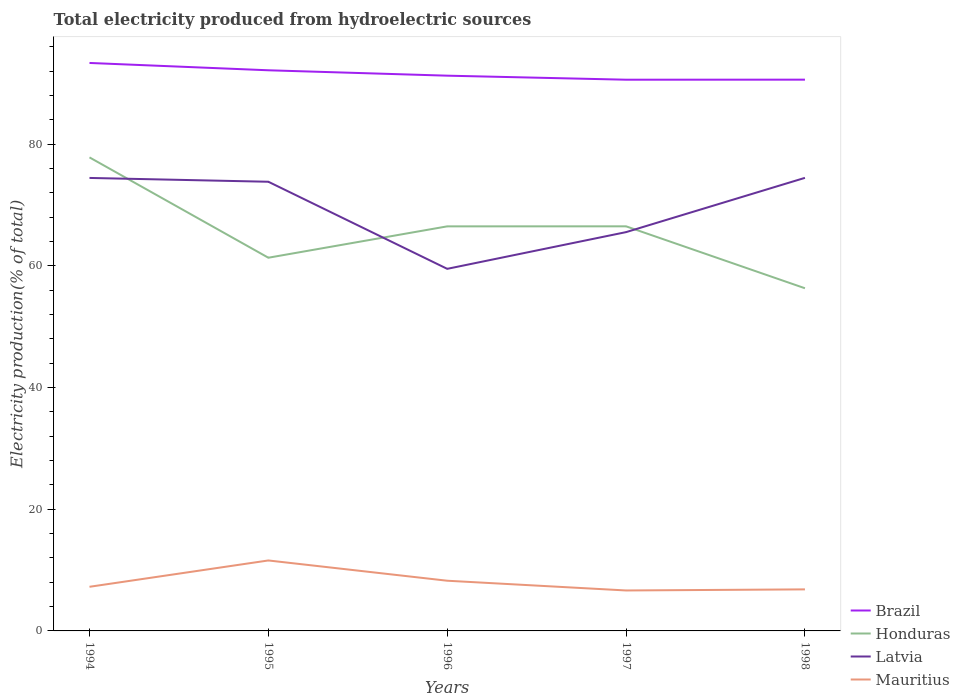How many different coloured lines are there?
Keep it short and to the point. 4. Across all years, what is the maximum total electricity produced in Brazil?
Ensure brevity in your answer.  90.58. What is the total total electricity produced in Latvia in the graph?
Your answer should be very brief. -14.95. What is the difference between the highest and the second highest total electricity produced in Latvia?
Provide a short and direct response. 14.95. How many years are there in the graph?
Provide a short and direct response. 5. Are the values on the major ticks of Y-axis written in scientific E-notation?
Your answer should be compact. No. Does the graph contain any zero values?
Offer a very short reply. No. Does the graph contain grids?
Offer a terse response. No. Where does the legend appear in the graph?
Your answer should be compact. Bottom right. What is the title of the graph?
Your answer should be compact. Total electricity produced from hydroelectric sources. What is the label or title of the Y-axis?
Your answer should be compact. Electricity production(% of total). What is the Electricity production(% of total) of Brazil in 1994?
Offer a terse response. 93.33. What is the Electricity production(% of total) of Honduras in 1994?
Offer a terse response. 77.82. What is the Electricity production(% of total) in Latvia in 1994?
Offer a very short reply. 74.44. What is the Electricity production(% of total) in Mauritius in 1994?
Your answer should be very brief. 7.25. What is the Electricity production(% of total) in Brazil in 1995?
Make the answer very short. 92.13. What is the Electricity production(% of total) of Honduras in 1995?
Your answer should be very brief. 61.33. What is the Electricity production(% of total) of Latvia in 1995?
Provide a succinct answer. 73.81. What is the Electricity production(% of total) of Mauritius in 1995?
Provide a succinct answer. 11.58. What is the Electricity production(% of total) in Brazil in 1996?
Provide a succinct answer. 91.24. What is the Electricity production(% of total) of Honduras in 1996?
Provide a short and direct response. 66.48. What is the Electricity production(% of total) of Latvia in 1996?
Your answer should be very brief. 59.5. What is the Electricity production(% of total) of Mauritius in 1996?
Your answer should be compact. 8.25. What is the Electricity production(% of total) of Brazil in 1997?
Your answer should be compact. 90.58. What is the Electricity production(% of total) in Honduras in 1997?
Your response must be concise. 66.49. What is the Electricity production(% of total) of Latvia in 1997?
Ensure brevity in your answer.  65.53. What is the Electricity production(% of total) in Mauritius in 1997?
Give a very brief answer. 6.65. What is the Electricity production(% of total) in Brazil in 1998?
Ensure brevity in your answer.  90.59. What is the Electricity production(% of total) in Honduras in 1998?
Provide a short and direct response. 56.31. What is the Electricity production(% of total) in Latvia in 1998?
Your answer should be compact. 74.45. What is the Electricity production(% of total) of Mauritius in 1998?
Your answer should be very brief. 6.83. Across all years, what is the maximum Electricity production(% of total) in Brazil?
Offer a terse response. 93.33. Across all years, what is the maximum Electricity production(% of total) of Honduras?
Make the answer very short. 77.82. Across all years, what is the maximum Electricity production(% of total) in Latvia?
Offer a terse response. 74.45. Across all years, what is the maximum Electricity production(% of total) of Mauritius?
Offer a terse response. 11.58. Across all years, what is the minimum Electricity production(% of total) in Brazil?
Ensure brevity in your answer.  90.58. Across all years, what is the minimum Electricity production(% of total) of Honduras?
Provide a short and direct response. 56.31. Across all years, what is the minimum Electricity production(% of total) in Latvia?
Provide a short and direct response. 59.5. Across all years, what is the minimum Electricity production(% of total) in Mauritius?
Your answer should be compact. 6.65. What is the total Electricity production(% of total) in Brazil in the graph?
Offer a terse response. 457.87. What is the total Electricity production(% of total) in Honduras in the graph?
Make the answer very short. 328.42. What is the total Electricity production(% of total) of Latvia in the graph?
Provide a short and direct response. 347.74. What is the total Electricity production(% of total) in Mauritius in the graph?
Offer a terse response. 40.55. What is the difference between the Electricity production(% of total) of Brazil in 1994 and that in 1995?
Your answer should be compact. 1.21. What is the difference between the Electricity production(% of total) of Honduras in 1994 and that in 1995?
Give a very brief answer. 16.49. What is the difference between the Electricity production(% of total) in Latvia in 1994 and that in 1995?
Give a very brief answer. 0.62. What is the difference between the Electricity production(% of total) of Mauritius in 1994 and that in 1995?
Provide a short and direct response. -4.33. What is the difference between the Electricity production(% of total) in Brazil in 1994 and that in 1996?
Your answer should be compact. 2.09. What is the difference between the Electricity production(% of total) in Honduras in 1994 and that in 1996?
Provide a succinct answer. 11.33. What is the difference between the Electricity production(% of total) in Latvia in 1994 and that in 1996?
Your answer should be very brief. 14.94. What is the difference between the Electricity production(% of total) of Mauritius in 1994 and that in 1996?
Keep it short and to the point. -1. What is the difference between the Electricity production(% of total) of Brazil in 1994 and that in 1997?
Keep it short and to the point. 2.75. What is the difference between the Electricity production(% of total) in Honduras in 1994 and that in 1997?
Provide a succinct answer. 11.33. What is the difference between the Electricity production(% of total) in Latvia in 1994 and that in 1997?
Provide a succinct answer. 8.9. What is the difference between the Electricity production(% of total) in Mauritius in 1994 and that in 1997?
Provide a succinct answer. 0.6. What is the difference between the Electricity production(% of total) of Brazil in 1994 and that in 1998?
Keep it short and to the point. 2.74. What is the difference between the Electricity production(% of total) of Honduras in 1994 and that in 1998?
Ensure brevity in your answer.  21.51. What is the difference between the Electricity production(% of total) of Latvia in 1994 and that in 1998?
Give a very brief answer. -0.02. What is the difference between the Electricity production(% of total) of Mauritius in 1994 and that in 1998?
Make the answer very short. 0.42. What is the difference between the Electricity production(% of total) in Brazil in 1995 and that in 1996?
Your response must be concise. 0.89. What is the difference between the Electricity production(% of total) in Honduras in 1995 and that in 1996?
Make the answer very short. -5.15. What is the difference between the Electricity production(% of total) of Latvia in 1995 and that in 1996?
Give a very brief answer. 14.31. What is the difference between the Electricity production(% of total) of Mauritius in 1995 and that in 1996?
Keep it short and to the point. 3.33. What is the difference between the Electricity production(% of total) in Brazil in 1995 and that in 1997?
Your answer should be very brief. 1.55. What is the difference between the Electricity production(% of total) in Honduras in 1995 and that in 1997?
Provide a succinct answer. -5.16. What is the difference between the Electricity production(% of total) in Latvia in 1995 and that in 1997?
Offer a very short reply. 8.28. What is the difference between the Electricity production(% of total) of Mauritius in 1995 and that in 1997?
Make the answer very short. 4.93. What is the difference between the Electricity production(% of total) in Brazil in 1995 and that in 1998?
Ensure brevity in your answer.  1.54. What is the difference between the Electricity production(% of total) of Honduras in 1995 and that in 1998?
Your answer should be very brief. 5.02. What is the difference between the Electricity production(% of total) in Latvia in 1995 and that in 1998?
Your answer should be compact. -0.64. What is the difference between the Electricity production(% of total) of Mauritius in 1995 and that in 1998?
Keep it short and to the point. 4.75. What is the difference between the Electricity production(% of total) of Brazil in 1996 and that in 1997?
Your answer should be very brief. 0.66. What is the difference between the Electricity production(% of total) of Honduras in 1996 and that in 1997?
Give a very brief answer. -0. What is the difference between the Electricity production(% of total) in Latvia in 1996 and that in 1997?
Keep it short and to the point. -6.03. What is the difference between the Electricity production(% of total) in Mauritius in 1996 and that in 1997?
Your response must be concise. 1.6. What is the difference between the Electricity production(% of total) in Brazil in 1996 and that in 1998?
Give a very brief answer. 0.65. What is the difference between the Electricity production(% of total) in Honduras in 1996 and that in 1998?
Keep it short and to the point. 10.17. What is the difference between the Electricity production(% of total) of Latvia in 1996 and that in 1998?
Keep it short and to the point. -14.95. What is the difference between the Electricity production(% of total) of Mauritius in 1996 and that in 1998?
Offer a very short reply. 1.42. What is the difference between the Electricity production(% of total) in Brazil in 1997 and that in 1998?
Your answer should be very brief. -0.01. What is the difference between the Electricity production(% of total) of Honduras in 1997 and that in 1998?
Your response must be concise. 10.18. What is the difference between the Electricity production(% of total) of Latvia in 1997 and that in 1998?
Your answer should be compact. -8.92. What is the difference between the Electricity production(% of total) in Mauritius in 1997 and that in 1998?
Offer a very short reply. -0.18. What is the difference between the Electricity production(% of total) of Brazil in 1994 and the Electricity production(% of total) of Honduras in 1995?
Your response must be concise. 32.01. What is the difference between the Electricity production(% of total) in Brazil in 1994 and the Electricity production(% of total) in Latvia in 1995?
Provide a short and direct response. 19.52. What is the difference between the Electricity production(% of total) of Brazil in 1994 and the Electricity production(% of total) of Mauritius in 1995?
Make the answer very short. 81.76. What is the difference between the Electricity production(% of total) in Honduras in 1994 and the Electricity production(% of total) in Latvia in 1995?
Your answer should be very brief. 4. What is the difference between the Electricity production(% of total) of Honduras in 1994 and the Electricity production(% of total) of Mauritius in 1995?
Give a very brief answer. 66.24. What is the difference between the Electricity production(% of total) in Latvia in 1994 and the Electricity production(% of total) in Mauritius in 1995?
Your answer should be compact. 62.86. What is the difference between the Electricity production(% of total) in Brazil in 1994 and the Electricity production(% of total) in Honduras in 1996?
Your answer should be very brief. 26.85. What is the difference between the Electricity production(% of total) in Brazil in 1994 and the Electricity production(% of total) in Latvia in 1996?
Ensure brevity in your answer.  33.83. What is the difference between the Electricity production(% of total) in Brazil in 1994 and the Electricity production(% of total) in Mauritius in 1996?
Offer a terse response. 85.09. What is the difference between the Electricity production(% of total) in Honduras in 1994 and the Electricity production(% of total) in Latvia in 1996?
Your answer should be compact. 18.31. What is the difference between the Electricity production(% of total) in Honduras in 1994 and the Electricity production(% of total) in Mauritius in 1996?
Provide a succinct answer. 69.57. What is the difference between the Electricity production(% of total) in Latvia in 1994 and the Electricity production(% of total) in Mauritius in 1996?
Ensure brevity in your answer.  66.19. What is the difference between the Electricity production(% of total) in Brazil in 1994 and the Electricity production(% of total) in Honduras in 1997?
Your answer should be compact. 26.85. What is the difference between the Electricity production(% of total) of Brazil in 1994 and the Electricity production(% of total) of Latvia in 1997?
Your response must be concise. 27.8. What is the difference between the Electricity production(% of total) of Brazil in 1994 and the Electricity production(% of total) of Mauritius in 1997?
Provide a succinct answer. 86.69. What is the difference between the Electricity production(% of total) in Honduras in 1994 and the Electricity production(% of total) in Latvia in 1997?
Offer a terse response. 12.28. What is the difference between the Electricity production(% of total) in Honduras in 1994 and the Electricity production(% of total) in Mauritius in 1997?
Ensure brevity in your answer.  71.17. What is the difference between the Electricity production(% of total) of Latvia in 1994 and the Electricity production(% of total) of Mauritius in 1997?
Keep it short and to the point. 67.79. What is the difference between the Electricity production(% of total) in Brazil in 1994 and the Electricity production(% of total) in Honduras in 1998?
Make the answer very short. 37.02. What is the difference between the Electricity production(% of total) in Brazil in 1994 and the Electricity production(% of total) in Latvia in 1998?
Give a very brief answer. 18.88. What is the difference between the Electricity production(% of total) in Brazil in 1994 and the Electricity production(% of total) in Mauritius in 1998?
Provide a short and direct response. 86.51. What is the difference between the Electricity production(% of total) in Honduras in 1994 and the Electricity production(% of total) in Latvia in 1998?
Your response must be concise. 3.36. What is the difference between the Electricity production(% of total) in Honduras in 1994 and the Electricity production(% of total) in Mauritius in 1998?
Your answer should be compact. 70.99. What is the difference between the Electricity production(% of total) of Latvia in 1994 and the Electricity production(% of total) of Mauritius in 1998?
Give a very brief answer. 67.61. What is the difference between the Electricity production(% of total) of Brazil in 1995 and the Electricity production(% of total) of Honduras in 1996?
Make the answer very short. 25.65. What is the difference between the Electricity production(% of total) in Brazil in 1995 and the Electricity production(% of total) in Latvia in 1996?
Make the answer very short. 32.63. What is the difference between the Electricity production(% of total) of Brazil in 1995 and the Electricity production(% of total) of Mauritius in 1996?
Your response must be concise. 83.88. What is the difference between the Electricity production(% of total) in Honduras in 1995 and the Electricity production(% of total) in Latvia in 1996?
Offer a terse response. 1.83. What is the difference between the Electricity production(% of total) of Honduras in 1995 and the Electricity production(% of total) of Mauritius in 1996?
Your response must be concise. 53.08. What is the difference between the Electricity production(% of total) in Latvia in 1995 and the Electricity production(% of total) in Mauritius in 1996?
Your response must be concise. 65.56. What is the difference between the Electricity production(% of total) of Brazil in 1995 and the Electricity production(% of total) of Honduras in 1997?
Your answer should be very brief. 25.64. What is the difference between the Electricity production(% of total) in Brazil in 1995 and the Electricity production(% of total) in Latvia in 1997?
Give a very brief answer. 26.59. What is the difference between the Electricity production(% of total) in Brazil in 1995 and the Electricity production(% of total) in Mauritius in 1997?
Your response must be concise. 85.48. What is the difference between the Electricity production(% of total) of Honduras in 1995 and the Electricity production(% of total) of Latvia in 1997?
Keep it short and to the point. -4.21. What is the difference between the Electricity production(% of total) of Honduras in 1995 and the Electricity production(% of total) of Mauritius in 1997?
Provide a short and direct response. 54.68. What is the difference between the Electricity production(% of total) of Latvia in 1995 and the Electricity production(% of total) of Mauritius in 1997?
Keep it short and to the point. 67.16. What is the difference between the Electricity production(% of total) of Brazil in 1995 and the Electricity production(% of total) of Honduras in 1998?
Offer a terse response. 35.82. What is the difference between the Electricity production(% of total) in Brazil in 1995 and the Electricity production(% of total) in Latvia in 1998?
Your answer should be compact. 17.68. What is the difference between the Electricity production(% of total) in Brazil in 1995 and the Electricity production(% of total) in Mauritius in 1998?
Your answer should be compact. 85.3. What is the difference between the Electricity production(% of total) of Honduras in 1995 and the Electricity production(% of total) of Latvia in 1998?
Provide a succinct answer. -13.13. What is the difference between the Electricity production(% of total) of Honduras in 1995 and the Electricity production(% of total) of Mauritius in 1998?
Your answer should be very brief. 54.5. What is the difference between the Electricity production(% of total) of Latvia in 1995 and the Electricity production(% of total) of Mauritius in 1998?
Your answer should be very brief. 66.99. What is the difference between the Electricity production(% of total) in Brazil in 1996 and the Electricity production(% of total) in Honduras in 1997?
Your answer should be compact. 24.76. What is the difference between the Electricity production(% of total) of Brazil in 1996 and the Electricity production(% of total) of Latvia in 1997?
Keep it short and to the point. 25.71. What is the difference between the Electricity production(% of total) in Brazil in 1996 and the Electricity production(% of total) in Mauritius in 1997?
Offer a terse response. 84.59. What is the difference between the Electricity production(% of total) of Honduras in 1996 and the Electricity production(% of total) of Latvia in 1997?
Keep it short and to the point. 0.95. What is the difference between the Electricity production(% of total) in Honduras in 1996 and the Electricity production(% of total) in Mauritius in 1997?
Your response must be concise. 59.83. What is the difference between the Electricity production(% of total) of Latvia in 1996 and the Electricity production(% of total) of Mauritius in 1997?
Make the answer very short. 52.85. What is the difference between the Electricity production(% of total) of Brazil in 1996 and the Electricity production(% of total) of Honduras in 1998?
Provide a short and direct response. 34.93. What is the difference between the Electricity production(% of total) of Brazil in 1996 and the Electricity production(% of total) of Latvia in 1998?
Make the answer very short. 16.79. What is the difference between the Electricity production(% of total) of Brazil in 1996 and the Electricity production(% of total) of Mauritius in 1998?
Your answer should be very brief. 84.42. What is the difference between the Electricity production(% of total) in Honduras in 1996 and the Electricity production(% of total) in Latvia in 1998?
Your answer should be very brief. -7.97. What is the difference between the Electricity production(% of total) of Honduras in 1996 and the Electricity production(% of total) of Mauritius in 1998?
Offer a very short reply. 59.65. What is the difference between the Electricity production(% of total) of Latvia in 1996 and the Electricity production(% of total) of Mauritius in 1998?
Your response must be concise. 52.67. What is the difference between the Electricity production(% of total) of Brazil in 1997 and the Electricity production(% of total) of Honduras in 1998?
Provide a succinct answer. 34.27. What is the difference between the Electricity production(% of total) in Brazil in 1997 and the Electricity production(% of total) in Latvia in 1998?
Your response must be concise. 16.13. What is the difference between the Electricity production(% of total) in Brazil in 1997 and the Electricity production(% of total) in Mauritius in 1998?
Provide a succinct answer. 83.75. What is the difference between the Electricity production(% of total) of Honduras in 1997 and the Electricity production(% of total) of Latvia in 1998?
Make the answer very short. -7.97. What is the difference between the Electricity production(% of total) of Honduras in 1997 and the Electricity production(% of total) of Mauritius in 1998?
Your answer should be compact. 59.66. What is the difference between the Electricity production(% of total) of Latvia in 1997 and the Electricity production(% of total) of Mauritius in 1998?
Give a very brief answer. 58.71. What is the average Electricity production(% of total) in Brazil per year?
Give a very brief answer. 91.57. What is the average Electricity production(% of total) of Honduras per year?
Your answer should be very brief. 65.68. What is the average Electricity production(% of total) of Latvia per year?
Make the answer very short. 69.55. What is the average Electricity production(% of total) of Mauritius per year?
Provide a succinct answer. 8.11. In the year 1994, what is the difference between the Electricity production(% of total) in Brazil and Electricity production(% of total) in Honduras?
Offer a terse response. 15.52. In the year 1994, what is the difference between the Electricity production(% of total) of Brazil and Electricity production(% of total) of Latvia?
Your answer should be compact. 18.9. In the year 1994, what is the difference between the Electricity production(% of total) in Brazil and Electricity production(% of total) in Mauritius?
Give a very brief answer. 86.08. In the year 1994, what is the difference between the Electricity production(% of total) in Honduras and Electricity production(% of total) in Latvia?
Provide a succinct answer. 3.38. In the year 1994, what is the difference between the Electricity production(% of total) of Honduras and Electricity production(% of total) of Mauritius?
Give a very brief answer. 70.56. In the year 1994, what is the difference between the Electricity production(% of total) of Latvia and Electricity production(% of total) of Mauritius?
Make the answer very short. 67.19. In the year 1995, what is the difference between the Electricity production(% of total) of Brazil and Electricity production(% of total) of Honduras?
Offer a very short reply. 30.8. In the year 1995, what is the difference between the Electricity production(% of total) in Brazil and Electricity production(% of total) in Latvia?
Offer a very short reply. 18.32. In the year 1995, what is the difference between the Electricity production(% of total) in Brazil and Electricity production(% of total) in Mauritius?
Your response must be concise. 80.55. In the year 1995, what is the difference between the Electricity production(% of total) in Honduras and Electricity production(% of total) in Latvia?
Your answer should be very brief. -12.49. In the year 1995, what is the difference between the Electricity production(% of total) in Honduras and Electricity production(% of total) in Mauritius?
Offer a terse response. 49.75. In the year 1995, what is the difference between the Electricity production(% of total) in Latvia and Electricity production(% of total) in Mauritius?
Offer a very short reply. 62.23. In the year 1996, what is the difference between the Electricity production(% of total) in Brazil and Electricity production(% of total) in Honduras?
Make the answer very short. 24.76. In the year 1996, what is the difference between the Electricity production(% of total) in Brazil and Electricity production(% of total) in Latvia?
Offer a terse response. 31.74. In the year 1996, what is the difference between the Electricity production(% of total) of Brazil and Electricity production(% of total) of Mauritius?
Make the answer very short. 82.99. In the year 1996, what is the difference between the Electricity production(% of total) of Honduras and Electricity production(% of total) of Latvia?
Your answer should be compact. 6.98. In the year 1996, what is the difference between the Electricity production(% of total) in Honduras and Electricity production(% of total) in Mauritius?
Your response must be concise. 58.23. In the year 1996, what is the difference between the Electricity production(% of total) of Latvia and Electricity production(% of total) of Mauritius?
Your answer should be very brief. 51.25. In the year 1997, what is the difference between the Electricity production(% of total) of Brazil and Electricity production(% of total) of Honduras?
Your response must be concise. 24.09. In the year 1997, what is the difference between the Electricity production(% of total) in Brazil and Electricity production(% of total) in Latvia?
Your response must be concise. 25.05. In the year 1997, what is the difference between the Electricity production(% of total) of Brazil and Electricity production(% of total) of Mauritius?
Provide a succinct answer. 83.93. In the year 1997, what is the difference between the Electricity production(% of total) of Honduras and Electricity production(% of total) of Latvia?
Your answer should be very brief. 0.95. In the year 1997, what is the difference between the Electricity production(% of total) in Honduras and Electricity production(% of total) in Mauritius?
Ensure brevity in your answer.  59.84. In the year 1997, what is the difference between the Electricity production(% of total) of Latvia and Electricity production(% of total) of Mauritius?
Your response must be concise. 58.89. In the year 1998, what is the difference between the Electricity production(% of total) in Brazil and Electricity production(% of total) in Honduras?
Offer a terse response. 34.28. In the year 1998, what is the difference between the Electricity production(% of total) of Brazil and Electricity production(% of total) of Latvia?
Ensure brevity in your answer.  16.14. In the year 1998, what is the difference between the Electricity production(% of total) of Brazil and Electricity production(% of total) of Mauritius?
Provide a succinct answer. 83.76. In the year 1998, what is the difference between the Electricity production(% of total) in Honduras and Electricity production(% of total) in Latvia?
Your answer should be compact. -18.14. In the year 1998, what is the difference between the Electricity production(% of total) of Honduras and Electricity production(% of total) of Mauritius?
Ensure brevity in your answer.  49.48. In the year 1998, what is the difference between the Electricity production(% of total) in Latvia and Electricity production(% of total) in Mauritius?
Ensure brevity in your answer.  67.63. What is the ratio of the Electricity production(% of total) in Brazil in 1994 to that in 1995?
Give a very brief answer. 1.01. What is the ratio of the Electricity production(% of total) of Honduras in 1994 to that in 1995?
Your answer should be compact. 1.27. What is the ratio of the Electricity production(% of total) of Latvia in 1994 to that in 1995?
Your answer should be compact. 1.01. What is the ratio of the Electricity production(% of total) of Mauritius in 1994 to that in 1995?
Ensure brevity in your answer.  0.63. What is the ratio of the Electricity production(% of total) in Brazil in 1994 to that in 1996?
Give a very brief answer. 1.02. What is the ratio of the Electricity production(% of total) in Honduras in 1994 to that in 1996?
Offer a terse response. 1.17. What is the ratio of the Electricity production(% of total) in Latvia in 1994 to that in 1996?
Your response must be concise. 1.25. What is the ratio of the Electricity production(% of total) of Mauritius in 1994 to that in 1996?
Ensure brevity in your answer.  0.88. What is the ratio of the Electricity production(% of total) in Brazil in 1994 to that in 1997?
Keep it short and to the point. 1.03. What is the ratio of the Electricity production(% of total) in Honduras in 1994 to that in 1997?
Ensure brevity in your answer.  1.17. What is the ratio of the Electricity production(% of total) in Latvia in 1994 to that in 1997?
Your answer should be compact. 1.14. What is the ratio of the Electricity production(% of total) of Brazil in 1994 to that in 1998?
Your response must be concise. 1.03. What is the ratio of the Electricity production(% of total) in Honduras in 1994 to that in 1998?
Your response must be concise. 1.38. What is the ratio of the Electricity production(% of total) in Mauritius in 1994 to that in 1998?
Give a very brief answer. 1.06. What is the ratio of the Electricity production(% of total) of Brazil in 1995 to that in 1996?
Make the answer very short. 1.01. What is the ratio of the Electricity production(% of total) of Honduras in 1995 to that in 1996?
Make the answer very short. 0.92. What is the ratio of the Electricity production(% of total) of Latvia in 1995 to that in 1996?
Your answer should be very brief. 1.24. What is the ratio of the Electricity production(% of total) in Mauritius in 1995 to that in 1996?
Ensure brevity in your answer.  1.4. What is the ratio of the Electricity production(% of total) in Brazil in 1995 to that in 1997?
Provide a succinct answer. 1.02. What is the ratio of the Electricity production(% of total) in Honduras in 1995 to that in 1997?
Your answer should be compact. 0.92. What is the ratio of the Electricity production(% of total) in Latvia in 1995 to that in 1997?
Ensure brevity in your answer.  1.13. What is the ratio of the Electricity production(% of total) in Mauritius in 1995 to that in 1997?
Your response must be concise. 1.74. What is the ratio of the Electricity production(% of total) of Brazil in 1995 to that in 1998?
Your answer should be compact. 1.02. What is the ratio of the Electricity production(% of total) of Honduras in 1995 to that in 1998?
Your answer should be compact. 1.09. What is the ratio of the Electricity production(% of total) in Mauritius in 1995 to that in 1998?
Your response must be concise. 1.7. What is the ratio of the Electricity production(% of total) in Brazil in 1996 to that in 1997?
Give a very brief answer. 1.01. What is the ratio of the Electricity production(% of total) in Latvia in 1996 to that in 1997?
Give a very brief answer. 0.91. What is the ratio of the Electricity production(% of total) of Mauritius in 1996 to that in 1997?
Make the answer very short. 1.24. What is the ratio of the Electricity production(% of total) of Brazil in 1996 to that in 1998?
Provide a short and direct response. 1.01. What is the ratio of the Electricity production(% of total) of Honduras in 1996 to that in 1998?
Provide a succinct answer. 1.18. What is the ratio of the Electricity production(% of total) in Latvia in 1996 to that in 1998?
Make the answer very short. 0.8. What is the ratio of the Electricity production(% of total) in Mauritius in 1996 to that in 1998?
Your answer should be very brief. 1.21. What is the ratio of the Electricity production(% of total) in Honduras in 1997 to that in 1998?
Provide a short and direct response. 1.18. What is the ratio of the Electricity production(% of total) of Latvia in 1997 to that in 1998?
Keep it short and to the point. 0.88. What is the ratio of the Electricity production(% of total) in Mauritius in 1997 to that in 1998?
Provide a short and direct response. 0.97. What is the difference between the highest and the second highest Electricity production(% of total) in Brazil?
Make the answer very short. 1.21. What is the difference between the highest and the second highest Electricity production(% of total) in Honduras?
Your answer should be very brief. 11.33. What is the difference between the highest and the second highest Electricity production(% of total) in Latvia?
Provide a succinct answer. 0.02. What is the difference between the highest and the second highest Electricity production(% of total) in Mauritius?
Keep it short and to the point. 3.33. What is the difference between the highest and the lowest Electricity production(% of total) of Brazil?
Ensure brevity in your answer.  2.75. What is the difference between the highest and the lowest Electricity production(% of total) of Honduras?
Provide a short and direct response. 21.51. What is the difference between the highest and the lowest Electricity production(% of total) of Latvia?
Offer a very short reply. 14.95. What is the difference between the highest and the lowest Electricity production(% of total) in Mauritius?
Give a very brief answer. 4.93. 